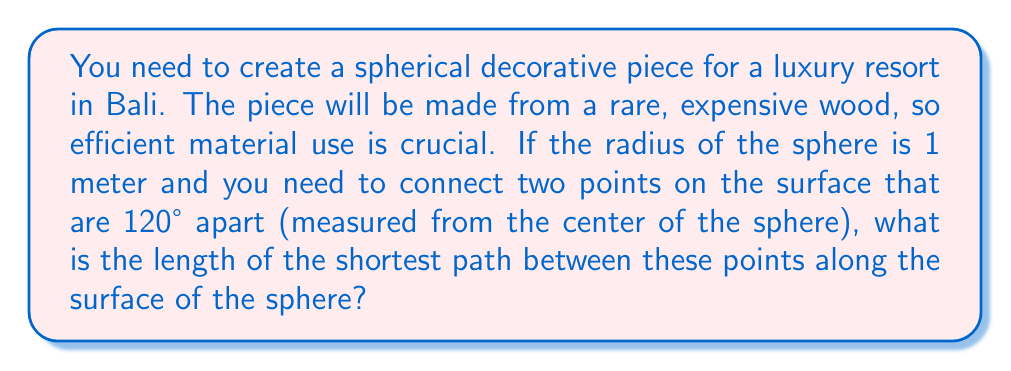Can you solve this math problem? To solve this problem, we need to use the concept of great circles in spherical geometry. The shortest path between two points on a sphere always lies on a great circle.

Step 1: Recall the formula for the arc length on a sphere:
$$s = r\theta$$
Where:
$s$ is the arc length
$r$ is the radius of the sphere
$\theta$ is the central angle in radians

Step 2: Convert the given angle from degrees to radians:
$$\theta = 120° \cdot \frac{\pi}{180°} = \frac{2\pi}{3} \text{ radians}$$

Step 3: Apply the formula using the given radius (1 meter) and the calculated angle in radians:
$$s = 1 \cdot \frac{2\pi}{3} = \frac{2\pi}{3} \text{ meters}$$

Step 4: Simplify the result:
$$s = \frac{2\pi}{3} \approx 2.0944 \text{ meters}$$

This length represents the most efficient use of material to connect the two points on the spherical surface.
Answer: $\frac{2\pi}{3}$ meters or approximately 2.0944 meters 